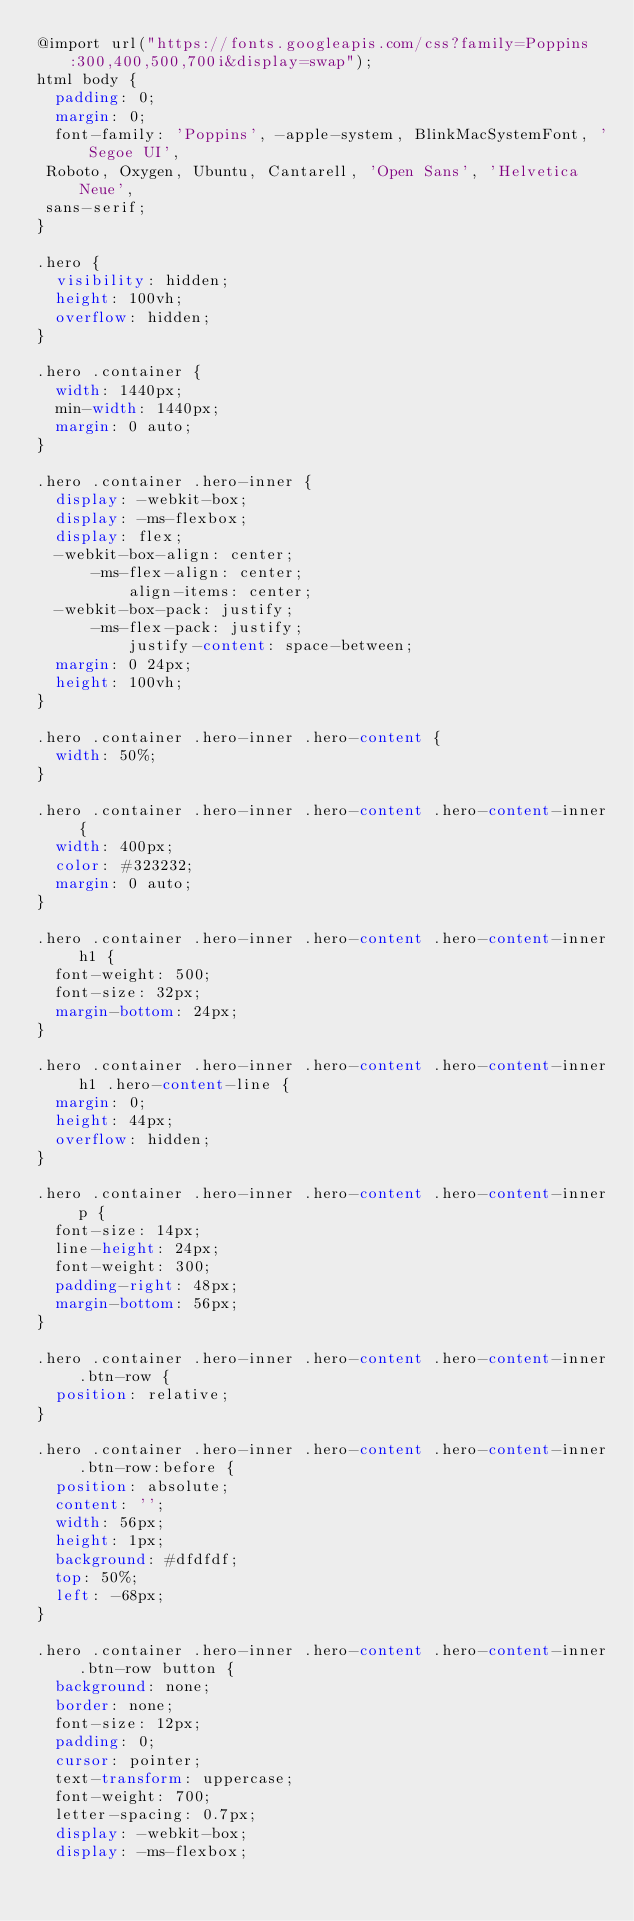Convert code to text. <code><loc_0><loc_0><loc_500><loc_500><_CSS_>@import url("https://fonts.googleapis.com/css?family=Poppins:300,400,500,700i&display=swap");
html body {
  padding: 0;
  margin: 0;
  font-family: 'Poppins', -apple-system, BlinkMacSystemFont, 'Segoe UI', Roboto, Oxygen, Ubuntu, Cantarell, 'Open Sans', 'Helvetica Neue', sans-serif;
}

.hero {
  visibility: hidden;
  height: 100vh;
  overflow: hidden;
}

.hero .container {
  width: 1440px;
  min-width: 1440px;
  margin: 0 auto;
}

.hero .container .hero-inner {
  display: -webkit-box;
  display: -ms-flexbox;
  display: flex;
  -webkit-box-align: center;
      -ms-flex-align: center;
          align-items: center;
  -webkit-box-pack: justify;
      -ms-flex-pack: justify;
          justify-content: space-between;
  margin: 0 24px;
  height: 100vh;
}

.hero .container .hero-inner .hero-content {
  width: 50%;
}

.hero .container .hero-inner .hero-content .hero-content-inner {
  width: 400px;
  color: #323232;
  margin: 0 auto;
}

.hero .container .hero-inner .hero-content .hero-content-inner h1 {
  font-weight: 500;
  font-size: 32px;
  margin-bottom: 24px;
}

.hero .container .hero-inner .hero-content .hero-content-inner h1 .hero-content-line {
  margin: 0;
  height: 44px;
  overflow: hidden;
}

.hero .container .hero-inner .hero-content .hero-content-inner p {
  font-size: 14px;
  line-height: 24px;
  font-weight: 300;
  padding-right: 48px;
  margin-bottom: 56px;
}

.hero .container .hero-inner .hero-content .hero-content-inner .btn-row {
  position: relative;
}

.hero .container .hero-inner .hero-content .hero-content-inner .btn-row:before {
  position: absolute;
  content: '';
  width: 56px;
  height: 1px;
  background: #dfdfdf;
  top: 50%;
  left: -68px;
}

.hero .container .hero-inner .hero-content .hero-content-inner .btn-row button {
  background: none;
  border: none;
  font-size: 12px;
  padding: 0;
  cursor: pointer;
  text-transform: uppercase;
  font-weight: 700;
  letter-spacing: 0.7px;
  display: -webkit-box;
  display: -ms-flexbox;</code> 